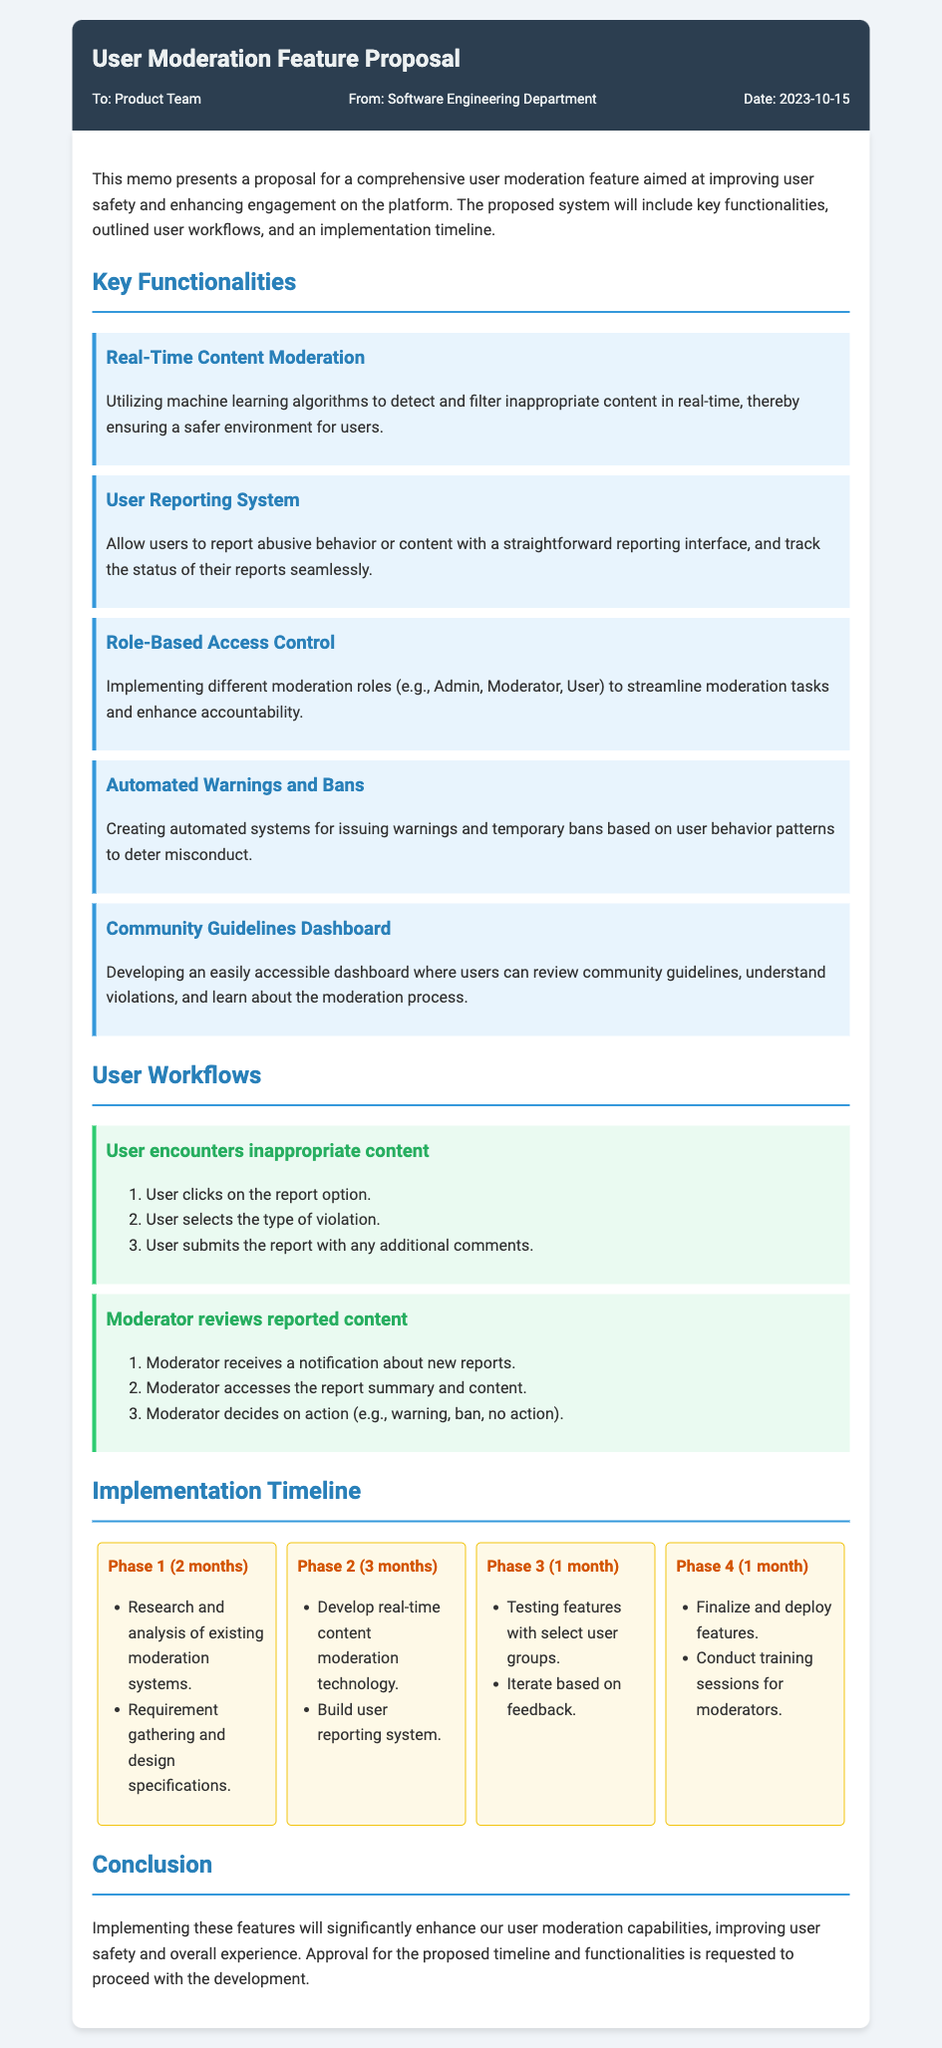What is the title of the memo? The title is displayed prominently at the top of the memo in a large font.
Answer: User Moderation Feature Proposal Who is the memo addressed to? The recipient of the memo is specified in the meta-info section.
Answer: Product Team What is the date of the memo? The date is included in the meta-info section of the document.
Answer: 2023-10-15 How many phases are outlined in the implementation timeline? The document lists distinct phases in the timeline section.
Answer: 4 What is the duration of Phase 2? The duration for each phase is detailed clearly in the timeline section.
Answer: 3 months Which functionality involves machine learning? The functionalities are listed with descriptions, including one that specifies the use of machine learning.
Answer: Real-Time Content Moderation What is the first step a user takes when encountering inappropriate content? The user workflow describes the initial action a user takes when faced with inappropriate content.
Answer: User clicks on the report option What feature allows users to track their reports? The functionality descriptions provide insight into user engagement features.
Answer: User Reporting System What is the purpose of the Community Guidelines Dashboard? The function of this feature is explained in the key functionalities section.
Answer: Understand violations What training will be conducted in Phase 4? The last phase outlines specific training provided to moderators.
Answer: Training sessions for moderators 